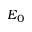Convert formula to latex. <formula><loc_0><loc_0><loc_500><loc_500>E _ { 0 }</formula> 